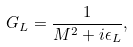<formula> <loc_0><loc_0><loc_500><loc_500>G _ { L } = \frac { 1 } { M ^ { 2 } + i \epsilon _ { L } } ,</formula> 